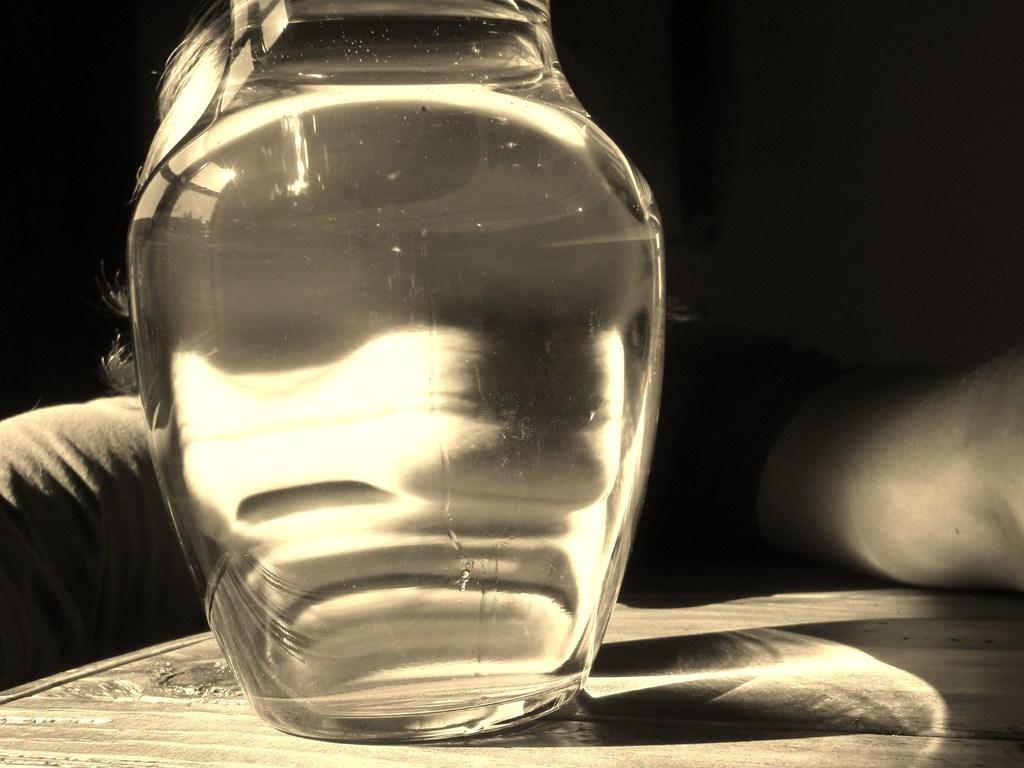What type of object is made of glass in the image? There is a glass object in the image. Can you describe the position of the glass object? The glass object is on a surface. What is the color of the background in the image? The background of the image is dark. What type of curtain is hanging in the image? There is no curtain present in the image. How many visitors can be seen in the image? There is no reference to any visitors in the image. 